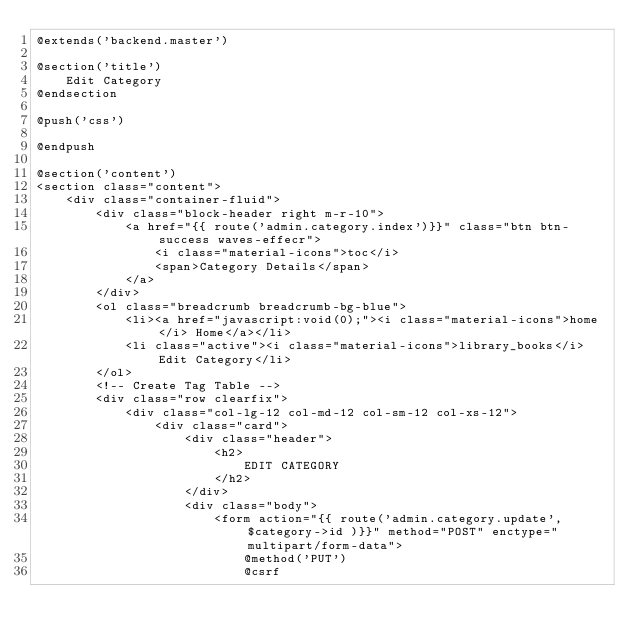<code> <loc_0><loc_0><loc_500><loc_500><_PHP_>@extends('backend.master')

@section('title')
    Edit Category
@endsection

@push('css') 

@endpush

@section('content')
<section class="content">
    <div class="container-fluid">
        <div class="block-header right m-r-10">
            <a href="{{ route('admin.category.index')}}" class="btn btn-success waves-effecr">
                <i class="material-icons">toc</i>
                <span>Category Details</span>
            </a>
        </div>
        <ol class="breadcrumb breadcrumb-bg-blue">
            <li><a href="javascript:void(0);"><i class="material-icons">home</i> Home</a></li>
            <li class="active"><i class="material-icons">library_books</i> Edit Category</li>
        </ol>
        <!-- Create Tag Table -->
        <div class="row clearfix">
            <div class="col-lg-12 col-md-12 col-sm-12 col-xs-12">
                <div class="card">
                    <div class="header">
                        <h2>
                            EDIT CATEGORY
                        </h2> 
                    </div>
                    <div class="body">
                        <form action="{{ route('admin.category.update',$category->id )}}" method="POST" enctype="multipart/form-data">
                            @method('PUT')
                            @csrf</code> 